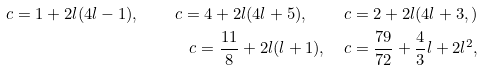<formula> <loc_0><loc_0><loc_500><loc_500>c = 1 + 2 l ( 4 l - 1 ) , \quad c = 4 + 2 l ( 4 l + 5 ) , \quad c = 2 + 2 l ( 4 l + 3 , ) \\ c = \frac { 1 1 } { 8 } + 2 l ( l + 1 ) , \quad c = \frac { 7 9 } { 7 2 } + \frac { 4 } { 3 } l + 2 l ^ { 2 } ,</formula> 